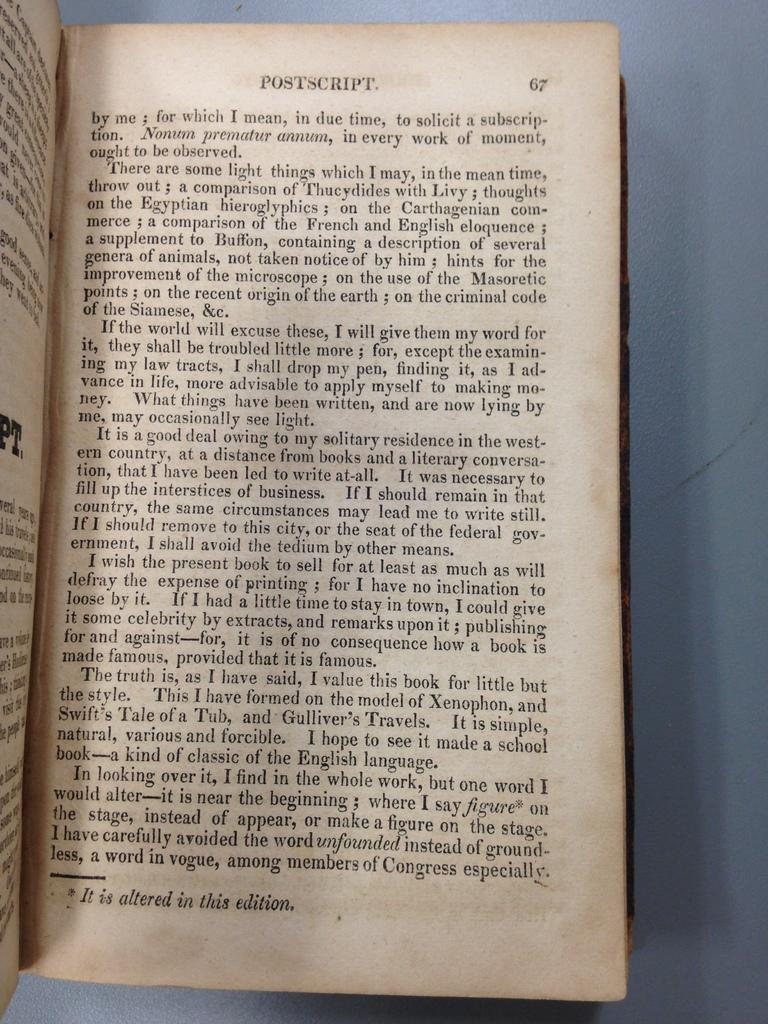Provide a one-sentence caption for the provided image. The open book is turned to page 67. 